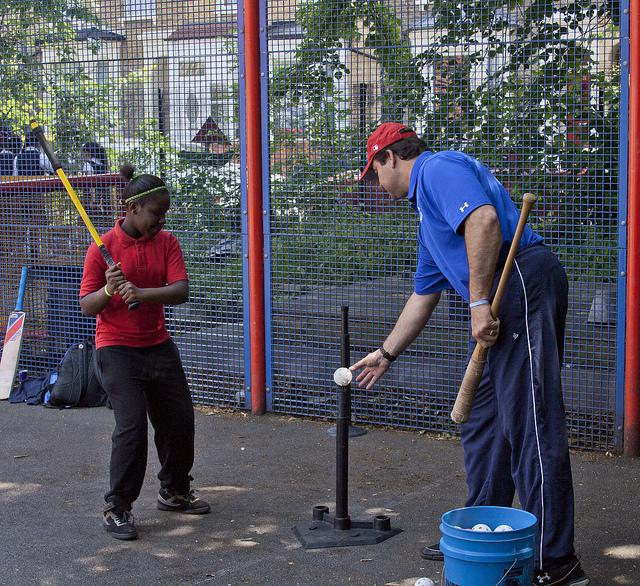What is the black pole the white ball is on called? Please explain your reasoning. batting tee. The pole is used to hit a ball. 